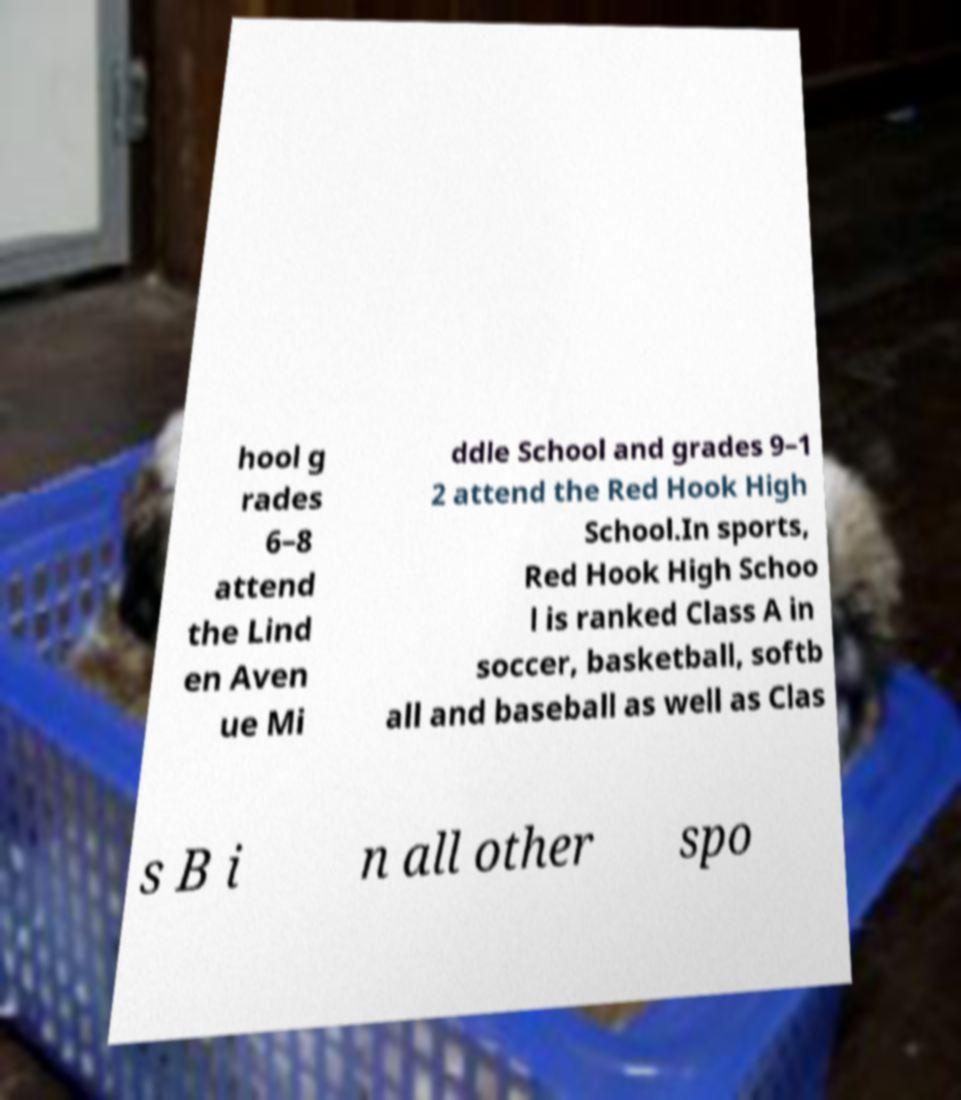Please read and relay the text visible in this image. What does it say? hool g rades 6–8 attend the Lind en Aven ue Mi ddle School and grades 9–1 2 attend the Red Hook High School.In sports, Red Hook High Schoo l is ranked Class A in soccer, basketball, softb all and baseball as well as Clas s B i n all other spo 